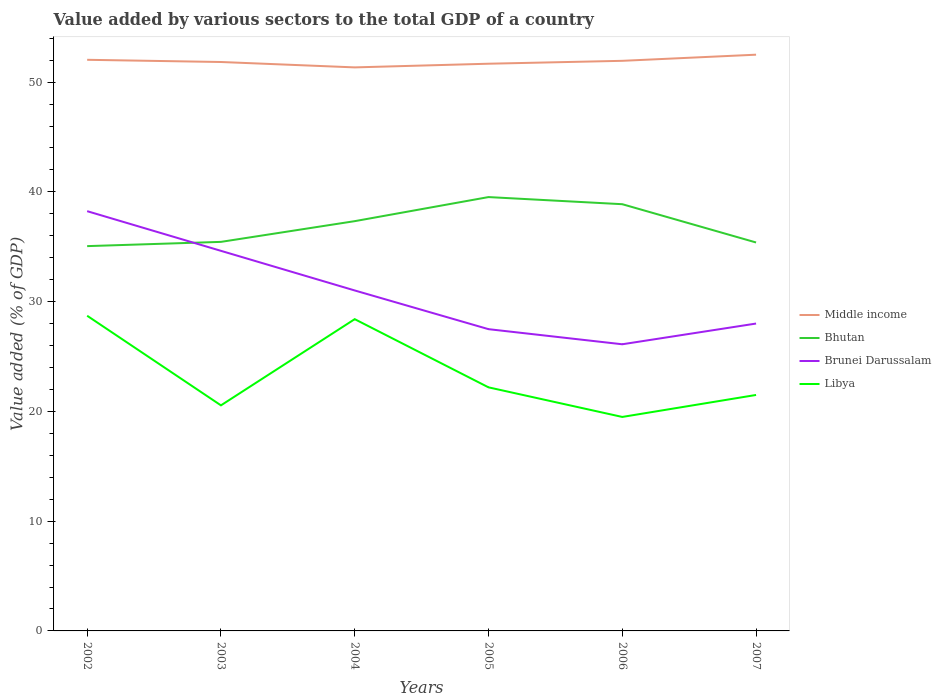How many different coloured lines are there?
Your response must be concise. 4. Across all years, what is the maximum value added by various sectors to the total GDP in Libya?
Provide a succinct answer. 19.5. What is the total value added by various sectors to the total GDP in Bhutan in the graph?
Give a very brief answer. -3.82. What is the difference between the highest and the second highest value added by various sectors to the total GDP in Bhutan?
Make the answer very short. 4.47. What is the difference between the highest and the lowest value added by various sectors to the total GDP in Brunei Darussalam?
Your answer should be very brief. 3. Is the value added by various sectors to the total GDP in Bhutan strictly greater than the value added by various sectors to the total GDP in Libya over the years?
Provide a succinct answer. No. How many lines are there?
Provide a short and direct response. 4. Are the values on the major ticks of Y-axis written in scientific E-notation?
Offer a very short reply. No. Does the graph contain any zero values?
Make the answer very short. No. Does the graph contain grids?
Your answer should be very brief. No. Where does the legend appear in the graph?
Provide a succinct answer. Center right. How are the legend labels stacked?
Offer a terse response. Vertical. What is the title of the graph?
Keep it short and to the point. Value added by various sectors to the total GDP of a country. What is the label or title of the Y-axis?
Ensure brevity in your answer.  Value added (% of GDP). What is the Value added (% of GDP) in Middle income in 2002?
Keep it short and to the point. 52.04. What is the Value added (% of GDP) in Bhutan in 2002?
Provide a succinct answer. 35.06. What is the Value added (% of GDP) in Brunei Darussalam in 2002?
Provide a succinct answer. 38.24. What is the Value added (% of GDP) of Libya in 2002?
Offer a terse response. 28.72. What is the Value added (% of GDP) in Middle income in 2003?
Your response must be concise. 51.84. What is the Value added (% of GDP) of Bhutan in 2003?
Keep it short and to the point. 35.45. What is the Value added (% of GDP) of Brunei Darussalam in 2003?
Offer a very short reply. 34.63. What is the Value added (% of GDP) in Libya in 2003?
Your answer should be very brief. 20.55. What is the Value added (% of GDP) of Middle income in 2004?
Offer a very short reply. 51.34. What is the Value added (% of GDP) of Bhutan in 2004?
Offer a terse response. 37.33. What is the Value added (% of GDP) in Brunei Darussalam in 2004?
Offer a terse response. 31.02. What is the Value added (% of GDP) of Libya in 2004?
Offer a terse response. 28.41. What is the Value added (% of GDP) of Middle income in 2005?
Provide a short and direct response. 51.68. What is the Value added (% of GDP) of Bhutan in 2005?
Your answer should be very brief. 39.53. What is the Value added (% of GDP) in Brunei Darussalam in 2005?
Provide a short and direct response. 27.49. What is the Value added (% of GDP) in Libya in 2005?
Offer a terse response. 22.19. What is the Value added (% of GDP) of Middle income in 2006?
Offer a very short reply. 51.94. What is the Value added (% of GDP) in Bhutan in 2006?
Provide a succinct answer. 38.88. What is the Value added (% of GDP) in Brunei Darussalam in 2006?
Provide a succinct answer. 26.12. What is the Value added (% of GDP) in Libya in 2006?
Provide a succinct answer. 19.5. What is the Value added (% of GDP) in Middle income in 2007?
Your answer should be very brief. 52.5. What is the Value added (% of GDP) of Bhutan in 2007?
Your answer should be compact. 35.39. What is the Value added (% of GDP) in Brunei Darussalam in 2007?
Your answer should be very brief. 28.01. What is the Value added (% of GDP) of Libya in 2007?
Provide a succinct answer. 21.5. Across all years, what is the maximum Value added (% of GDP) of Middle income?
Make the answer very short. 52.5. Across all years, what is the maximum Value added (% of GDP) of Bhutan?
Keep it short and to the point. 39.53. Across all years, what is the maximum Value added (% of GDP) of Brunei Darussalam?
Your answer should be very brief. 38.24. Across all years, what is the maximum Value added (% of GDP) of Libya?
Your answer should be compact. 28.72. Across all years, what is the minimum Value added (% of GDP) of Middle income?
Provide a short and direct response. 51.34. Across all years, what is the minimum Value added (% of GDP) in Bhutan?
Make the answer very short. 35.06. Across all years, what is the minimum Value added (% of GDP) in Brunei Darussalam?
Ensure brevity in your answer.  26.12. Across all years, what is the minimum Value added (% of GDP) of Libya?
Offer a terse response. 19.5. What is the total Value added (% of GDP) of Middle income in the graph?
Keep it short and to the point. 311.34. What is the total Value added (% of GDP) in Bhutan in the graph?
Your response must be concise. 221.64. What is the total Value added (% of GDP) of Brunei Darussalam in the graph?
Give a very brief answer. 185.51. What is the total Value added (% of GDP) of Libya in the graph?
Keep it short and to the point. 140.86. What is the difference between the Value added (% of GDP) in Middle income in 2002 and that in 2003?
Your response must be concise. 0.2. What is the difference between the Value added (% of GDP) in Bhutan in 2002 and that in 2003?
Provide a succinct answer. -0.39. What is the difference between the Value added (% of GDP) of Brunei Darussalam in 2002 and that in 2003?
Give a very brief answer. 3.61. What is the difference between the Value added (% of GDP) of Libya in 2002 and that in 2003?
Ensure brevity in your answer.  8.16. What is the difference between the Value added (% of GDP) in Middle income in 2002 and that in 2004?
Your answer should be compact. 0.69. What is the difference between the Value added (% of GDP) in Bhutan in 2002 and that in 2004?
Offer a very short reply. -2.28. What is the difference between the Value added (% of GDP) in Brunei Darussalam in 2002 and that in 2004?
Give a very brief answer. 7.22. What is the difference between the Value added (% of GDP) of Libya in 2002 and that in 2004?
Offer a terse response. 0.31. What is the difference between the Value added (% of GDP) in Middle income in 2002 and that in 2005?
Offer a terse response. 0.36. What is the difference between the Value added (% of GDP) of Bhutan in 2002 and that in 2005?
Your answer should be compact. -4.47. What is the difference between the Value added (% of GDP) in Brunei Darussalam in 2002 and that in 2005?
Make the answer very short. 10.75. What is the difference between the Value added (% of GDP) of Libya in 2002 and that in 2005?
Provide a short and direct response. 6.52. What is the difference between the Value added (% of GDP) of Middle income in 2002 and that in 2006?
Keep it short and to the point. 0.09. What is the difference between the Value added (% of GDP) in Bhutan in 2002 and that in 2006?
Offer a terse response. -3.82. What is the difference between the Value added (% of GDP) of Brunei Darussalam in 2002 and that in 2006?
Ensure brevity in your answer.  12.13. What is the difference between the Value added (% of GDP) in Libya in 2002 and that in 2006?
Your answer should be very brief. 9.22. What is the difference between the Value added (% of GDP) in Middle income in 2002 and that in 2007?
Provide a short and direct response. -0.47. What is the difference between the Value added (% of GDP) in Brunei Darussalam in 2002 and that in 2007?
Provide a succinct answer. 10.24. What is the difference between the Value added (% of GDP) of Libya in 2002 and that in 2007?
Keep it short and to the point. 7.22. What is the difference between the Value added (% of GDP) of Middle income in 2003 and that in 2004?
Your answer should be very brief. 0.49. What is the difference between the Value added (% of GDP) of Bhutan in 2003 and that in 2004?
Make the answer very short. -1.89. What is the difference between the Value added (% of GDP) in Brunei Darussalam in 2003 and that in 2004?
Provide a short and direct response. 3.61. What is the difference between the Value added (% of GDP) of Libya in 2003 and that in 2004?
Your answer should be compact. -7.85. What is the difference between the Value added (% of GDP) in Middle income in 2003 and that in 2005?
Provide a succinct answer. 0.16. What is the difference between the Value added (% of GDP) of Bhutan in 2003 and that in 2005?
Your response must be concise. -4.08. What is the difference between the Value added (% of GDP) of Brunei Darussalam in 2003 and that in 2005?
Your answer should be very brief. 7.14. What is the difference between the Value added (% of GDP) in Libya in 2003 and that in 2005?
Offer a terse response. -1.64. What is the difference between the Value added (% of GDP) in Middle income in 2003 and that in 2006?
Offer a very short reply. -0.11. What is the difference between the Value added (% of GDP) in Bhutan in 2003 and that in 2006?
Provide a short and direct response. -3.43. What is the difference between the Value added (% of GDP) in Brunei Darussalam in 2003 and that in 2006?
Your response must be concise. 8.51. What is the difference between the Value added (% of GDP) of Libya in 2003 and that in 2006?
Your answer should be compact. 1.06. What is the difference between the Value added (% of GDP) of Middle income in 2003 and that in 2007?
Offer a terse response. -0.67. What is the difference between the Value added (% of GDP) in Bhutan in 2003 and that in 2007?
Your answer should be very brief. 0.05. What is the difference between the Value added (% of GDP) in Brunei Darussalam in 2003 and that in 2007?
Make the answer very short. 6.62. What is the difference between the Value added (% of GDP) of Libya in 2003 and that in 2007?
Offer a terse response. -0.95. What is the difference between the Value added (% of GDP) in Middle income in 2004 and that in 2005?
Ensure brevity in your answer.  -0.33. What is the difference between the Value added (% of GDP) of Bhutan in 2004 and that in 2005?
Your response must be concise. -2.19. What is the difference between the Value added (% of GDP) of Brunei Darussalam in 2004 and that in 2005?
Provide a succinct answer. 3.53. What is the difference between the Value added (% of GDP) in Libya in 2004 and that in 2005?
Ensure brevity in your answer.  6.21. What is the difference between the Value added (% of GDP) in Middle income in 2004 and that in 2006?
Provide a short and direct response. -0.6. What is the difference between the Value added (% of GDP) in Bhutan in 2004 and that in 2006?
Your answer should be very brief. -1.54. What is the difference between the Value added (% of GDP) of Brunei Darussalam in 2004 and that in 2006?
Your answer should be very brief. 4.9. What is the difference between the Value added (% of GDP) in Libya in 2004 and that in 2006?
Provide a short and direct response. 8.91. What is the difference between the Value added (% of GDP) in Middle income in 2004 and that in 2007?
Offer a very short reply. -1.16. What is the difference between the Value added (% of GDP) in Bhutan in 2004 and that in 2007?
Keep it short and to the point. 1.94. What is the difference between the Value added (% of GDP) in Brunei Darussalam in 2004 and that in 2007?
Provide a short and direct response. 3.01. What is the difference between the Value added (% of GDP) of Libya in 2004 and that in 2007?
Keep it short and to the point. 6.91. What is the difference between the Value added (% of GDP) of Middle income in 2005 and that in 2006?
Your answer should be very brief. -0.26. What is the difference between the Value added (% of GDP) of Bhutan in 2005 and that in 2006?
Provide a short and direct response. 0.65. What is the difference between the Value added (% of GDP) of Brunei Darussalam in 2005 and that in 2006?
Make the answer very short. 1.38. What is the difference between the Value added (% of GDP) in Libya in 2005 and that in 2006?
Ensure brevity in your answer.  2.7. What is the difference between the Value added (% of GDP) of Middle income in 2005 and that in 2007?
Offer a terse response. -0.82. What is the difference between the Value added (% of GDP) in Bhutan in 2005 and that in 2007?
Your answer should be compact. 4.14. What is the difference between the Value added (% of GDP) in Brunei Darussalam in 2005 and that in 2007?
Ensure brevity in your answer.  -0.51. What is the difference between the Value added (% of GDP) of Libya in 2005 and that in 2007?
Offer a terse response. 0.69. What is the difference between the Value added (% of GDP) in Middle income in 2006 and that in 2007?
Make the answer very short. -0.56. What is the difference between the Value added (% of GDP) in Bhutan in 2006 and that in 2007?
Offer a very short reply. 3.49. What is the difference between the Value added (% of GDP) of Brunei Darussalam in 2006 and that in 2007?
Your response must be concise. -1.89. What is the difference between the Value added (% of GDP) in Libya in 2006 and that in 2007?
Give a very brief answer. -2. What is the difference between the Value added (% of GDP) in Middle income in 2002 and the Value added (% of GDP) in Bhutan in 2003?
Make the answer very short. 16.59. What is the difference between the Value added (% of GDP) of Middle income in 2002 and the Value added (% of GDP) of Brunei Darussalam in 2003?
Offer a very short reply. 17.41. What is the difference between the Value added (% of GDP) of Middle income in 2002 and the Value added (% of GDP) of Libya in 2003?
Give a very brief answer. 31.48. What is the difference between the Value added (% of GDP) in Bhutan in 2002 and the Value added (% of GDP) in Brunei Darussalam in 2003?
Keep it short and to the point. 0.43. What is the difference between the Value added (% of GDP) of Bhutan in 2002 and the Value added (% of GDP) of Libya in 2003?
Make the answer very short. 14.51. What is the difference between the Value added (% of GDP) in Brunei Darussalam in 2002 and the Value added (% of GDP) in Libya in 2003?
Offer a terse response. 17.69. What is the difference between the Value added (% of GDP) in Middle income in 2002 and the Value added (% of GDP) in Bhutan in 2004?
Provide a short and direct response. 14.7. What is the difference between the Value added (% of GDP) of Middle income in 2002 and the Value added (% of GDP) of Brunei Darussalam in 2004?
Ensure brevity in your answer.  21.02. What is the difference between the Value added (% of GDP) of Middle income in 2002 and the Value added (% of GDP) of Libya in 2004?
Provide a short and direct response. 23.63. What is the difference between the Value added (% of GDP) of Bhutan in 2002 and the Value added (% of GDP) of Brunei Darussalam in 2004?
Offer a terse response. 4.04. What is the difference between the Value added (% of GDP) in Bhutan in 2002 and the Value added (% of GDP) in Libya in 2004?
Provide a succinct answer. 6.65. What is the difference between the Value added (% of GDP) in Brunei Darussalam in 2002 and the Value added (% of GDP) in Libya in 2004?
Give a very brief answer. 9.84. What is the difference between the Value added (% of GDP) in Middle income in 2002 and the Value added (% of GDP) in Bhutan in 2005?
Provide a succinct answer. 12.51. What is the difference between the Value added (% of GDP) in Middle income in 2002 and the Value added (% of GDP) in Brunei Darussalam in 2005?
Offer a terse response. 24.54. What is the difference between the Value added (% of GDP) of Middle income in 2002 and the Value added (% of GDP) of Libya in 2005?
Offer a very short reply. 29.84. What is the difference between the Value added (% of GDP) in Bhutan in 2002 and the Value added (% of GDP) in Brunei Darussalam in 2005?
Give a very brief answer. 7.57. What is the difference between the Value added (% of GDP) of Bhutan in 2002 and the Value added (% of GDP) of Libya in 2005?
Offer a very short reply. 12.87. What is the difference between the Value added (% of GDP) of Brunei Darussalam in 2002 and the Value added (% of GDP) of Libya in 2005?
Offer a very short reply. 16.05. What is the difference between the Value added (% of GDP) in Middle income in 2002 and the Value added (% of GDP) in Bhutan in 2006?
Make the answer very short. 13.16. What is the difference between the Value added (% of GDP) in Middle income in 2002 and the Value added (% of GDP) in Brunei Darussalam in 2006?
Offer a very short reply. 25.92. What is the difference between the Value added (% of GDP) in Middle income in 2002 and the Value added (% of GDP) in Libya in 2006?
Your response must be concise. 32.54. What is the difference between the Value added (% of GDP) in Bhutan in 2002 and the Value added (% of GDP) in Brunei Darussalam in 2006?
Keep it short and to the point. 8.94. What is the difference between the Value added (% of GDP) of Bhutan in 2002 and the Value added (% of GDP) of Libya in 2006?
Keep it short and to the point. 15.56. What is the difference between the Value added (% of GDP) in Brunei Darussalam in 2002 and the Value added (% of GDP) in Libya in 2006?
Your response must be concise. 18.75. What is the difference between the Value added (% of GDP) of Middle income in 2002 and the Value added (% of GDP) of Bhutan in 2007?
Provide a succinct answer. 16.64. What is the difference between the Value added (% of GDP) of Middle income in 2002 and the Value added (% of GDP) of Brunei Darussalam in 2007?
Provide a succinct answer. 24.03. What is the difference between the Value added (% of GDP) in Middle income in 2002 and the Value added (% of GDP) in Libya in 2007?
Give a very brief answer. 30.54. What is the difference between the Value added (% of GDP) in Bhutan in 2002 and the Value added (% of GDP) in Brunei Darussalam in 2007?
Your response must be concise. 7.05. What is the difference between the Value added (% of GDP) of Bhutan in 2002 and the Value added (% of GDP) of Libya in 2007?
Ensure brevity in your answer.  13.56. What is the difference between the Value added (% of GDP) in Brunei Darussalam in 2002 and the Value added (% of GDP) in Libya in 2007?
Provide a succinct answer. 16.75. What is the difference between the Value added (% of GDP) in Middle income in 2003 and the Value added (% of GDP) in Bhutan in 2004?
Your answer should be compact. 14.5. What is the difference between the Value added (% of GDP) in Middle income in 2003 and the Value added (% of GDP) in Brunei Darussalam in 2004?
Offer a terse response. 20.82. What is the difference between the Value added (% of GDP) of Middle income in 2003 and the Value added (% of GDP) of Libya in 2004?
Provide a succinct answer. 23.43. What is the difference between the Value added (% of GDP) of Bhutan in 2003 and the Value added (% of GDP) of Brunei Darussalam in 2004?
Ensure brevity in your answer.  4.43. What is the difference between the Value added (% of GDP) of Bhutan in 2003 and the Value added (% of GDP) of Libya in 2004?
Your answer should be compact. 7.04. What is the difference between the Value added (% of GDP) in Brunei Darussalam in 2003 and the Value added (% of GDP) in Libya in 2004?
Provide a short and direct response. 6.22. What is the difference between the Value added (% of GDP) in Middle income in 2003 and the Value added (% of GDP) in Bhutan in 2005?
Your response must be concise. 12.31. What is the difference between the Value added (% of GDP) of Middle income in 2003 and the Value added (% of GDP) of Brunei Darussalam in 2005?
Ensure brevity in your answer.  24.34. What is the difference between the Value added (% of GDP) in Middle income in 2003 and the Value added (% of GDP) in Libya in 2005?
Provide a short and direct response. 29.64. What is the difference between the Value added (% of GDP) of Bhutan in 2003 and the Value added (% of GDP) of Brunei Darussalam in 2005?
Your answer should be compact. 7.95. What is the difference between the Value added (% of GDP) of Bhutan in 2003 and the Value added (% of GDP) of Libya in 2005?
Offer a very short reply. 13.25. What is the difference between the Value added (% of GDP) in Brunei Darussalam in 2003 and the Value added (% of GDP) in Libya in 2005?
Provide a succinct answer. 12.44. What is the difference between the Value added (% of GDP) in Middle income in 2003 and the Value added (% of GDP) in Bhutan in 2006?
Offer a very short reply. 12.96. What is the difference between the Value added (% of GDP) of Middle income in 2003 and the Value added (% of GDP) of Brunei Darussalam in 2006?
Provide a short and direct response. 25.72. What is the difference between the Value added (% of GDP) of Middle income in 2003 and the Value added (% of GDP) of Libya in 2006?
Offer a very short reply. 32.34. What is the difference between the Value added (% of GDP) of Bhutan in 2003 and the Value added (% of GDP) of Brunei Darussalam in 2006?
Your answer should be compact. 9.33. What is the difference between the Value added (% of GDP) in Bhutan in 2003 and the Value added (% of GDP) in Libya in 2006?
Your answer should be very brief. 15.95. What is the difference between the Value added (% of GDP) of Brunei Darussalam in 2003 and the Value added (% of GDP) of Libya in 2006?
Make the answer very short. 15.13. What is the difference between the Value added (% of GDP) in Middle income in 2003 and the Value added (% of GDP) in Bhutan in 2007?
Your answer should be compact. 16.44. What is the difference between the Value added (% of GDP) of Middle income in 2003 and the Value added (% of GDP) of Brunei Darussalam in 2007?
Offer a terse response. 23.83. What is the difference between the Value added (% of GDP) in Middle income in 2003 and the Value added (% of GDP) in Libya in 2007?
Provide a short and direct response. 30.34. What is the difference between the Value added (% of GDP) of Bhutan in 2003 and the Value added (% of GDP) of Brunei Darussalam in 2007?
Your response must be concise. 7.44. What is the difference between the Value added (% of GDP) of Bhutan in 2003 and the Value added (% of GDP) of Libya in 2007?
Keep it short and to the point. 13.95. What is the difference between the Value added (% of GDP) in Brunei Darussalam in 2003 and the Value added (% of GDP) in Libya in 2007?
Your answer should be compact. 13.13. What is the difference between the Value added (% of GDP) in Middle income in 2004 and the Value added (% of GDP) in Bhutan in 2005?
Make the answer very short. 11.82. What is the difference between the Value added (% of GDP) of Middle income in 2004 and the Value added (% of GDP) of Brunei Darussalam in 2005?
Provide a short and direct response. 23.85. What is the difference between the Value added (% of GDP) of Middle income in 2004 and the Value added (% of GDP) of Libya in 2005?
Offer a very short reply. 29.15. What is the difference between the Value added (% of GDP) of Bhutan in 2004 and the Value added (% of GDP) of Brunei Darussalam in 2005?
Provide a succinct answer. 9.84. What is the difference between the Value added (% of GDP) in Bhutan in 2004 and the Value added (% of GDP) in Libya in 2005?
Your answer should be compact. 15.14. What is the difference between the Value added (% of GDP) of Brunei Darussalam in 2004 and the Value added (% of GDP) of Libya in 2005?
Offer a terse response. 8.83. What is the difference between the Value added (% of GDP) in Middle income in 2004 and the Value added (% of GDP) in Bhutan in 2006?
Make the answer very short. 12.47. What is the difference between the Value added (% of GDP) of Middle income in 2004 and the Value added (% of GDP) of Brunei Darussalam in 2006?
Make the answer very short. 25.23. What is the difference between the Value added (% of GDP) in Middle income in 2004 and the Value added (% of GDP) in Libya in 2006?
Your answer should be very brief. 31.85. What is the difference between the Value added (% of GDP) of Bhutan in 2004 and the Value added (% of GDP) of Brunei Darussalam in 2006?
Make the answer very short. 11.22. What is the difference between the Value added (% of GDP) of Bhutan in 2004 and the Value added (% of GDP) of Libya in 2006?
Make the answer very short. 17.84. What is the difference between the Value added (% of GDP) of Brunei Darussalam in 2004 and the Value added (% of GDP) of Libya in 2006?
Offer a very short reply. 11.52. What is the difference between the Value added (% of GDP) of Middle income in 2004 and the Value added (% of GDP) of Bhutan in 2007?
Give a very brief answer. 15.95. What is the difference between the Value added (% of GDP) in Middle income in 2004 and the Value added (% of GDP) in Brunei Darussalam in 2007?
Ensure brevity in your answer.  23.34. What is the difference between the Value added (% of GDP) in Middle income in 2004 and the Value added (% of GDP) in Libya in 2007?
Your answer should be very brief. 29.85. What is the difference between the Value added (% of GDP) in Bhutan in 2004 and the Value added (% of GDP) in Brunei Darussalam in 2007?
Ensure brevity in your answer.  9.33. What is the difference between the Value added (% of GDP) of Bhutan in 2004 and the Value added (% of GDP) of Libya in 2007?
Give a very brief answer. 15.83. What is the difference between the Value added (% of GDP) in Brunei Darussalam in 2004 and the Value added (% of GDP) in Libya in 2007?
Your answer should be compact. 9.52. What is the difference between the Value added (% of GDP) of Middle income in 2005 and the Value added (% of GDP) of Bhutan in 2006?
Your answer should be very brief. 12.8. What is the difference between the Value added (% of GDP) in Middle income in 2005 and the Value added (% of GDP) in Brunei Darussalam in 2006?
Provide a short and direct response. 25.56. What is the difference between the Value added (% of GDP) of Middle income in 2005 and the Value added (% of GDP) of Libya in 2006?
Keep it short and to the point. 32.18. What is the difference between the Value added (% of GDP) of Bhutan in 2005 and the Value added (% of GDP) of Brunei Darussalam in 2006?
Offer a very short reply. 13.41. What is the difference between the Value added (% of GDP) of Bhutan in 2005 and the Value added (% of GDP) of Libya in 2006?
Make the answer very short. 20.03. What is the difference between the Value added (% of GDP) of Brunei Darussalam in 2005 and the Value added (% of GDP) of Libya in 2006?
Ensure brevity in your answer.  8. What is the difference between the Value added (% of GDP) in Middle income in 2005 and the Value added (% of GDP) in Bhutan in 2007?
Ensure brevity in your answer.  16.29. What is the difference between the Value added (% of GDP) of Middle income in 2005 and the Value added (% of GDP) of Brunei Darussalam in 2007?
Provide a short and direct response. 23.67. What is the difference between the Value added (% of GDP) of Middle income in 2005 and the Value added (% of GDP) of Libya in 2007?
Offer a terse response. 30.18. What is the difference between the Value added (% of GDP) of Bhutan in 2005 and the Value added (% of GDP) of Brunei Darussalam in 2007?
Your response must be concise. 11.52. What is the difference between the Value added (% of GDP) of Bhutan in 2005 and the Value added (% of GDP) of Libya in 2007?
Make the answer very short. 18.03. What is the difference between the Value added (% of GDP) in Brunei Darussalam in 2005 and the Value added (% of GDP) in Libya in 2007?
Your answer should be very brief. 5.99. What is the difference between the Value added (% of GDP) of Middle income in 2006 and the Value added (% of GDP) of Bhutan in 2007?
Make the answer very short. 16.55. What is the difference between the Value added (% of GDP) in Middle income in 2006 and the Value added (% of GDP) in Brunei Darussalam in 2007?
Offer a very short reply. 23.94. What is the difference between the Value added (% of GDP) of Middle income in 2006 and the Value added (% of GDP) of Libya in 2007?
Provide a succinct answer. 30.44. What is the difference between the Value added (% of GDP) of Bhutan in 2006 and the Value added (% of GDP) of Brunei Darussalam in 2007?
Offer a terse response. 10.87. What is the difference between the Value added (% of GDP) of Bhutan in 2006 and the Value added (% of GDP) of Libya in 2007?
Your answer should be very brief. 17.38. What is the difference between the Value added (% of GDP) in Brunei Darussalam in 2006 and the Value added (% of GDP) in Libya in 2007?
Give a very brief answer. 4.62. What is the average Value added (% of GDP) of Middle income per year?
Your answer should be compact. 51.89. What is the average Value added (% of GDP) in Bhutan per year?
Keep it short and to the point. 36.94. What is the average Value added (% of GDP) in Brunei Darussalam per year?
Give a very brief answer. 30.92. What is the average Value added (% of GDP) in Libya per year?
Ensure brevity in your answer.  23.48. In the year 2002, what is the difference between the Value added (% of GDP) of Middle income and Value added (% of GDP) of Bhutan?
Ensure brevity in your answer.  16.98. In the year 2002, what is the difference between the Value added (% of GDP) in Middle income and Value added (% of GDP) in Brunei Darussalam?
Give a very brief answer. 13.79. In the year 2002, what is the difference between the Value added (% of GDP) in Middle income and Value added (% of GDP) in Libya?
Your answer should be compact. 23.32. In the year 2002, what is the difference between the Value added (% of GDP) of Bhutan and Value added (% of GDP) of Brunei Darussalam?
Keep it short and to the point. -3.19. In the year 2002, what is the difference between the Value added (% of GDP) in Bhutan and Value added (% of GDP) in Libya?
Make the answer very short. 6.34. In the year 2002, what is the difference between the Value added (% of GDP) of Brunei Darussalam and Value added (% of GDP) of Libya?
Give a very brief answer. 9.53. In the year 2003, what is the difference between the Value added (% of GDP) of Middle income and Value added (% of GDP) of Bhutan?
Your response must be concise. 16.39. In the year 2003, what is the difference between the Value added (% of GDP) in Middle income and Value added (% of GDP) in Brunei Darussalam?
Your answer should be compact. 17.21. In the year 2003, what is the difference between the Value added (% of GDP) in Middle income and Value added (% of GDP) in Libya?
Provide a short and direct response. 31.28. In the year 2003, what is the difference between the Value added (% of GDP) in Bhutan and Value added (% of GDP) in Brunei Darussalam?
Provide a short and direct response. 0.82. In the year 2003, what is the difference between the Value added (% of GDP) of Bhutan and Value added (% of GDP) of Libya?
Provide a short and direct response. 14.9. In the year 2003, what is the difference between the Value added (% of GDP) of Brunei Darussalam and Value added (% of GDP) of Libya?
Ensure brevity in your answer.  14.08. In the year 2004, what is the difference between the Value added (% of GDP) in Middle income and Value added (% of GDP) in Bhutan?
Provide a succinct answer. 14.01. In the year 2004, what is the difference between the Value added (% of GDP) of Middle income and Value added (% of GDP) of Brunei Darussalam?
Offer a terse response. 20.32. In the year 2004, what is the difference between the Value added (% of GDP) in Middle income and Value added (% of GDP) in Libya?
Offer a terse response. 22.94. In the year 2004, what is the difference between the Value added (% of GDP) in Bhutan and Value added (% of GDP) in Brunei Darussalam?
Provide a succinct answer. 6.31. In the year 2004, what is the difference between the Value added (% of GDP) of Bhutan and Value added (% of GDP) of Libya?
Give a very brief answer. 8.93. In the year 2004, what is the difference between the Value added (% of GDP) of Brunei Darussalam and Value added (% of GDP) of Libya?
Make the answer very short. 2.61. In the year 2005, what is the difference between the Value added (% of GDP) in Middle income and Value added (% of GDP) in Bhutan?
Your response must be concise. 12.15. In the year 2005, what is the difference between the Value added (% of GDP) in Middle income and Value added (% of GDP) in Brunei Darussalam?
Provide a succinct answer. 24.19. In the year 2005, what is the difference between the Value added (% of GDP) of Middle income and Value added (% of GDP) of Libya?
Make the answer very short. 29.49. In the year 2005, what is the difference between the Value added (% of GDP) of Bhutan and Value added (% of GDP) of Brunei Darussalam?
Your response must be concise. 12.03. In the year 2005, what is the difference between the Value added (% of GDP) in Bhutan and Value added (% of GDP) in Libya?
Give a very brief answer. 17.33. In the year 2005, what is the difference between the Value added (% of GDP) of Brunei Darussalam and Value added (% of GDP) of Libya?
Give a very brief answer. 5.3. In the year 2006, what is the difference between the Value added (% of GDP) of Middle income and Value added (% of GDP) of Bhutan?
Offer a terse response. 13.06. In the year 2006, what is the difference between the Value added (% of GDP) in Middle income and Value added (% of GDP) in Brunei Darussalam?
Your answer should be compact. 25.83. In the year 2006, what is the difference between the Value added (% of GDP) in Middle income and Value added (% of GDP) in Libya?
Your answer should be compact. 32.45. In the year 2006, what is the difference between the Value added (% of GDP) of Bhutan and Value added (% of GDP) of Brunei Darussalam?
Keep it short and to the point. 12.76. In the year 2006, what is the difference between the Value added (% of GDP) in Bhutan and Value added (% of GDP) in Libya?
Ensure brevity in your answer.  19.38. In the year 2006, what is the difference between the Value added (% of GDP) in Brunei Darussalam and Value added (% of GDP) in Libya?
Keep it short and to the point. 6.62. In the year 2007, what is the difference between the Value added (% of GDP) in Middle income and Value added (% of GDP) in Bhutan?
Give a very brief answer. 17.11. In the year 2007, what is the difference between the Value added (% of GDP) in Middle income and Value added (% of GDP) in Brunei Darussalam?
Ensure brevity in your answer.  24.5. In the year 2007, what is the difference between the Value added (% of GDP) of Middle income and Value added (% of GDP) of Libya?
Offer a very short reply. 31. In the year 2007, what is the difference between the Value added (% of GDP) in Bhutan and Value added (% of GDP) in Brunei Darussalam?
Offer a very short reply. 7.39. In the year 2007, what is the difference between the Value added (% of GDP) in Bhutan and Value added (% of GDP) in Libya?
Your response must be concise. 13.89. In the year 2007, what is the difference between the Value added (% of GDP) in Brunei Darussalam and Value added (% of GDP) in Libya?
Your answer should be very brief. 6.51. What is the ratio of the Value added (% of GDP) of Bhutan in 2002 to that in 2003?
Your answer should be compact. 0.99. What is the ratio of the Value added (% of GDP) of Brunei Darussalam in 2002 to that in 2003?
Offer a terse response. 1.1. What is the ratio of the Value added (% of GDP) of Libya in 2002 to that in 2003?
Provide a succinct answer. 1.4. What is the ratio of the Value added (% of GDP) of Middle income in 2002 to that in 2004?
Your answer should be compact. 1.01. What is the ratio of the Value added (% of GDP) in Bhutan in 2002 to that in 2004?
Your response must be concise. 0.94. What is the ratio of the Value added (% of GDP) in Brunei Darussalam in 2002 to that in 2004?
Your answer should be very brief. 1.23. What is the ratio of the Value added (% of GDP) in Libya in 2002 to that in 2004?
Give a very brief answer. 1.01. What is the ratio of the Value added (% of GDP) of Bhutan in 2002 to that in 2005?
Give a very brief answer. 0.89. What is the ratio of the Value added (% of GDP) of Brunei Darussalam in 2002 to that in 2005?
Provide a succinct answer. 1.39. What is the ratio of the Value added (% of GDP) in Libya in 2002 to that in 2005?
Offer a very short reply. 1.29. What is the ratio of the Value added (% of GDP) of Bhutan in 2002 to that in 2006?
Your response must be concise. 0.9. What is the ratio of the Value added (% of GDP) of Brunei Darussalam in 2002 to that in 2006?
Your answer should be very brief. 1.46. What is the ratio of the Value added (% of GDP) of Libya in 2002 to that in 2006?
Offer a very short reply. 1.47. What is the ratio of the Value added (% of GDP) of Bhutan in 2002 to that in 2007?
Provide a succinct answer. 0.99. What is the ratio of the Value added (% of GDP) in Brunei Darussalam in 2002 to that in 2007?
Your answer should be very brief. 1.37. What is the ratio of the Value added (% of GDP) of Libya in 2002 to that in 2007?
Offer a terse response. 1.34. What is the ratio of the Value added (% of GDP) of Middle income in 2003 to that in 2004?
Make the answer very short. 1.01. What is the ratio of the Value added (% of GDP) of Bhutan in 2003 to that in 2004?
Provide a succinct answer. 0.95. What is the ratio of the Value added (% of GDP) in Brunei Darussalam in 2003 to that in 2004?
Provide a short and direct response. 1.12. What is the ratio of the Value added (% of GDP) of Libya in 2003 to that in 2004?
Ensure brevity in your answer.  0.72. What is the ratio of the Value added (% of GDP) of Bhutan in 2003 to that in 2005?
Your answer should be compact. 0.9. What is the ratio of the Value added (% of GDP) in Brunei Darussalam in 2003 to that in 2005?
Your response must be concise. 1.26. What is the ratio of the Value added (% of GDP) of Libya in 2003 to that in 2005?
Your answer should be compact. 0.93. What is the ratio of the Value added (% of GDP) of Middle income in 2003 to that in 2006?
Offer a terse response. 1. What is the ratio of the Value added (% of GDP) of Bhutan in 2003 to that in 2006?
Give a very brief answer. 0.91. What is the ratio of the Value added (% of GDP) in Brunei Darussalam in 2003 to that in 2006?
Provide a short and direct response. 1.33. What is the ratio of the Value added (% of GDP) of Libya in 2003 to that in 2006?
Provide a short and direct response. 1.05. What is the ratio of the Value added (% of GDP) of Middle income in 2003 to that in 2007?
Ensure brevity in your answer.  0.99. What is the ratio of the Value added (% of GDP) of Bhutan in 2003 to that in 2007?
Ensure brevity in your answer.  1. What is the ratio of the Value added (% of GDP) of Brunei Darussalam in 2003 to that in 2007?
Your response must be concise. 1.24. What is the ratio of the Value added (% of GDP) in Libya in 2003 to that in 2007?
Provide a short and direct response. 0.96. What is the ratio of the Value added (% of GDP) in Bhutan in 2004 to that in 2005?
Make the answer very short. 0.94. What is the ratio of the Value added (% of GDP) of Brunei Darussalam in 2004 to that in 2005?
Give a very brief answer. 1.13. What is the ratio of the Value added (% of GDP) of Libya in 2004 to that in 2005?
Offer a very short reply. 1.28. What is the ratio of the Value added (% of GDP) of Middle income in 2004 to that in 2006?
Your answer should be very brief. 0.99. What is the ratio of the Value added (% of GDP) in Bhutan in 2004 to that in 2006?
Offer a very short reply. 0.96. What is the ratio of the Value added (% of GDP) in Brunei Darussalam in 2004 to that in 2006?
Provide a short and direct response. 1.19. What is the ratio of the Value added (% of GDP) of Libya in 2004 to that in 2006?
Keep it short and to the point. 1.46. What is the ratio of the Value added (% of GDP) in Bhutan in 2004 to that in 2007?
Your answer should be very brief. 1.05. What is the ratio of the Value added (% of GDP) in Brunei Darussalam in 2004 to that in 2007?
Your answer should be very brief. 1.11. What is the ratio of the Value added (% of GDP) of Libya in 2004 to that in 2007?
Provide a succinct answer. 1.32. What is the ratio of the Value added (% of GDP) in Middle income in 2005 to that in 2006?
Provide a short and direct response. 0.99. What is the ratio of the Value added (% of GDP) of Bhutan in 2005 to that in 2006?
Give a very brief answer. 1.02. What is the ratio of the Value added (% of GDP) in Brunei Darussalam in 2005 to that in 2006?
Your answer should be very brief. 1.05. What is the ratio of the Value added (% of GDP) in Libya in 2005 to that in 2006?
Your answer should be compact. 1.14. What is the ratio of the Value added (% of GDP) in Middle income in 2005 to that in 2007?
Ensure brevity in your answer.  0.98. What is the ratio of the Value added (% of GDP) of Bhutan in 2005 to that in 2007?
Offer a very short reply. 1.12. What is the ratio of the Value added (% of GDP) in Brunei Darussalam in 2005 to that in 2007?
Keep it short and to the point. 0.98. What is the ratio of the Value added (% of GDP) of Libya in 2005 to that in 2007?
Your response must be concise. 1.03. What is the ratio of the Value added (% of GDP) in Middle income in 2006 to that in 2007?
Offer a terse response. 0.99. What is the ratio of the Value added (% of GDP) in Bhutan in 2006 to that in 2007?
Provide a short and direct response. 1.1. What is the ratio of the Value added (% of GDP) of Brunei Darussalam in 2006 to that in 2007?
Provide a succinct answer. 0.93. What is the ratio of the Value added (% of GDP) in Libya in 2006 to that in 2007?
Provide a short and direct response. 0.91. What is the difference between the highest and the second highest Value added (% of GDP) in Middle income?
Offer a very short reply. 0.47. What is the difference between the highest and the second highest Value added (% of GDP) in Bhutan?
Your answer should be very brief. 0.65. What is the difference between the highest and the second highest Value added (% of GDP) in Brunei Darussalam?
Offer a very short reply. 3.61. What is the difference between the highest and the second highest Value added (% of GDP) in Libya?
Your response must be concise. 0.31. What is the difference between the highest and the lowest Value added (% of GDP) in Middle income?
Offer a very short reply. 1.16. What is the difference between the highest and the lowest Value added (% of GDP) of Bhutan?
Give a very brief answer. 4.47. What is the difference between the highest and the lowest Value added (% of GDP) in Brunei Darussalam?
Offer a terse response. 12.13. What is the difference between the highest and the lowest Value added (% of GDP) in Libya?
Provide a succinct answer. 9.22. 